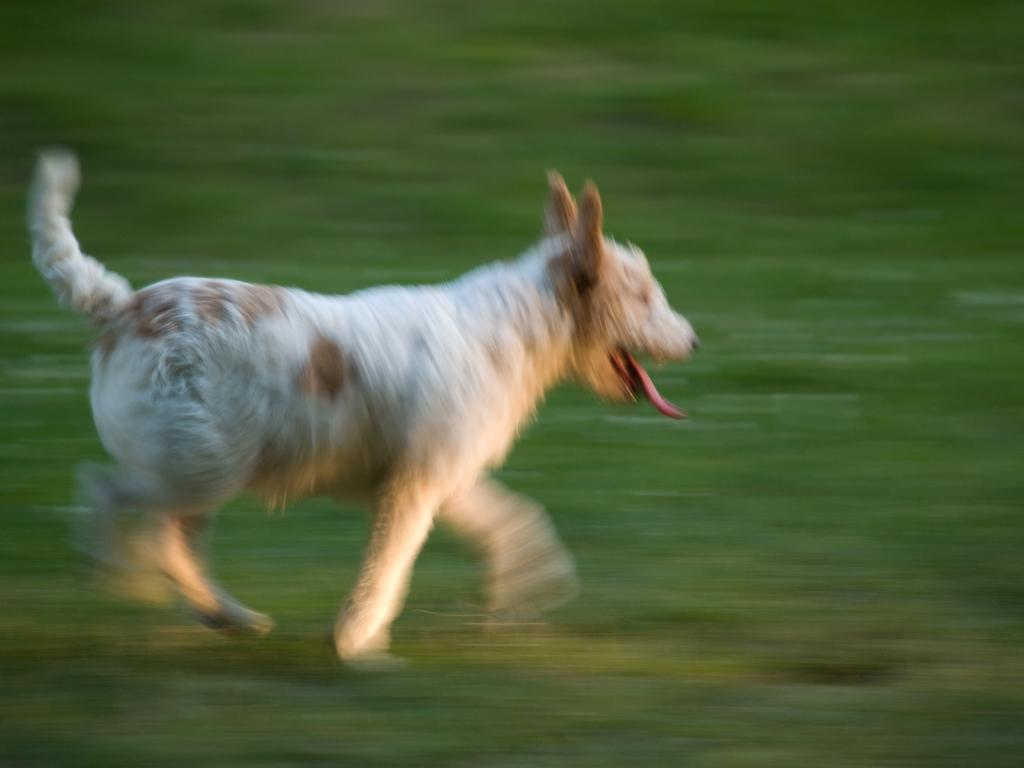What animal is present in the image? There is a dog in the image. Can you describe the background of the image? The background of the image is blurred. What type of comfort can be seen in the image? There is no specific type of comfort present in the image; it features a dog and a blurred background. 